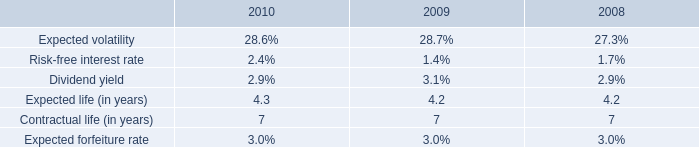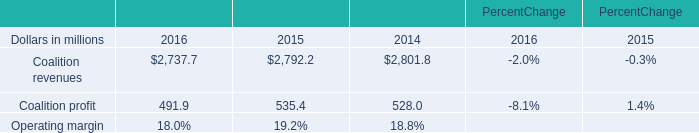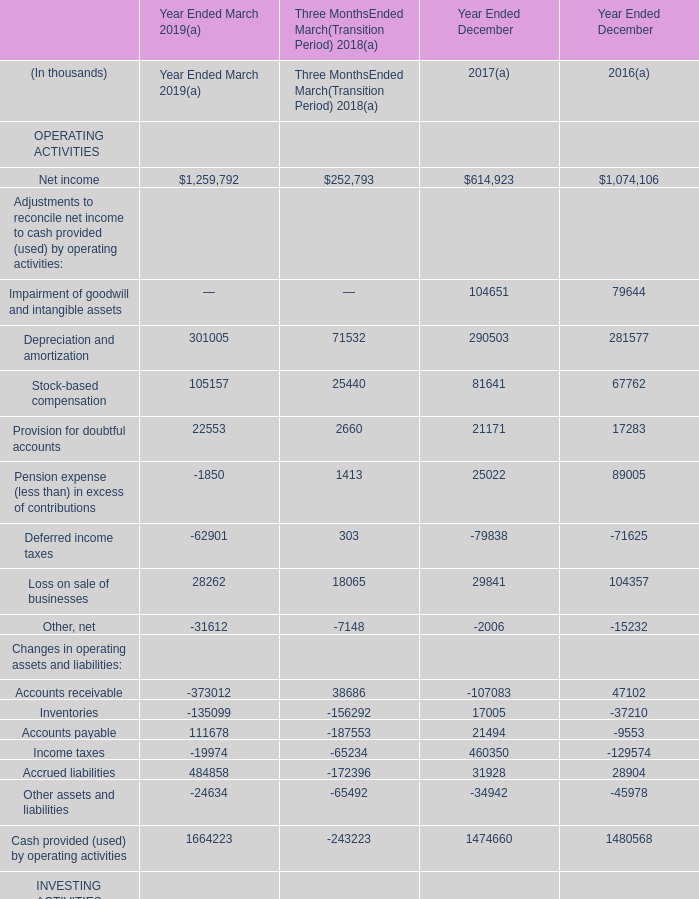what was the percentage growth in the weighted-average estimated fair values of stock options granted from 2009 to 2010 
Computations: ((5.28 - 3.79) / 3.79)
Answer: 0.39314. 